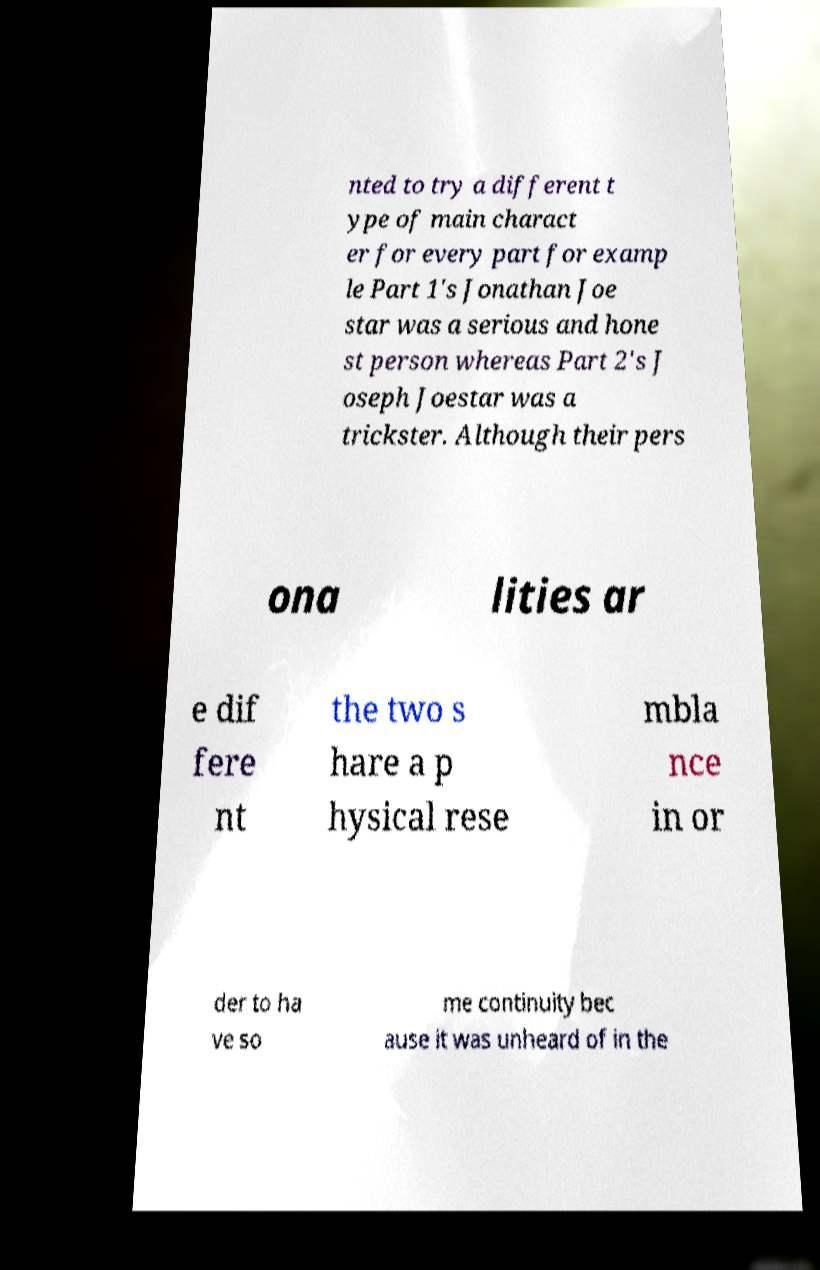Could you extract and type out the text from this image? nted to try a different t ype of main charact er for every part for examp le Part 1's Jonathan Joe star was a serious and hone st person whereas Part 2's J oseph Joestar was a trickster. Although their pers ona lities ar e dif fere nt the two s hare a p hysical rese mbla nce in or der to ha ve so me continuity bec ause it was unheard of in the 